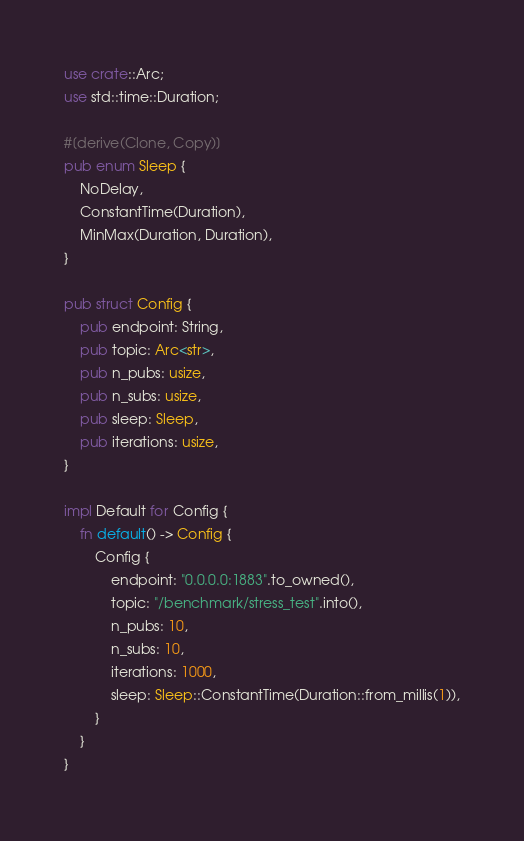Convert code to text. <code><loc_0><loc_0><loc_500><loc_500><_Rust_>use crate::Arc;
use std::time::Duration;

#[derive(Clone, Copy)]
pub enum Sleep {
    NoDelay,
    ConstantTime(Duration),
    MinMax(Duration, Duration),
}

pub struct Config {
    pub endpoint: String,
    pub topic: Arc<str>,
    pub n_pubs: usize,
    pub n_subs: usize,
    pub sleep: Sleep,
    pub iterations: usize,
}

impl Default for Config {
    fn default() -> Config {
        Config {
            endpoint: "0.0.0.0:1883".to_owned(),
            topic: "/benchmark/stress_test".into(),
            n_pubs: 10,
            n_subs: 10,
            iterations: 1000,
            sleep: Sleep::ConstantTime(Duration::from_millis(1)),
        }
    }
}
</code> 